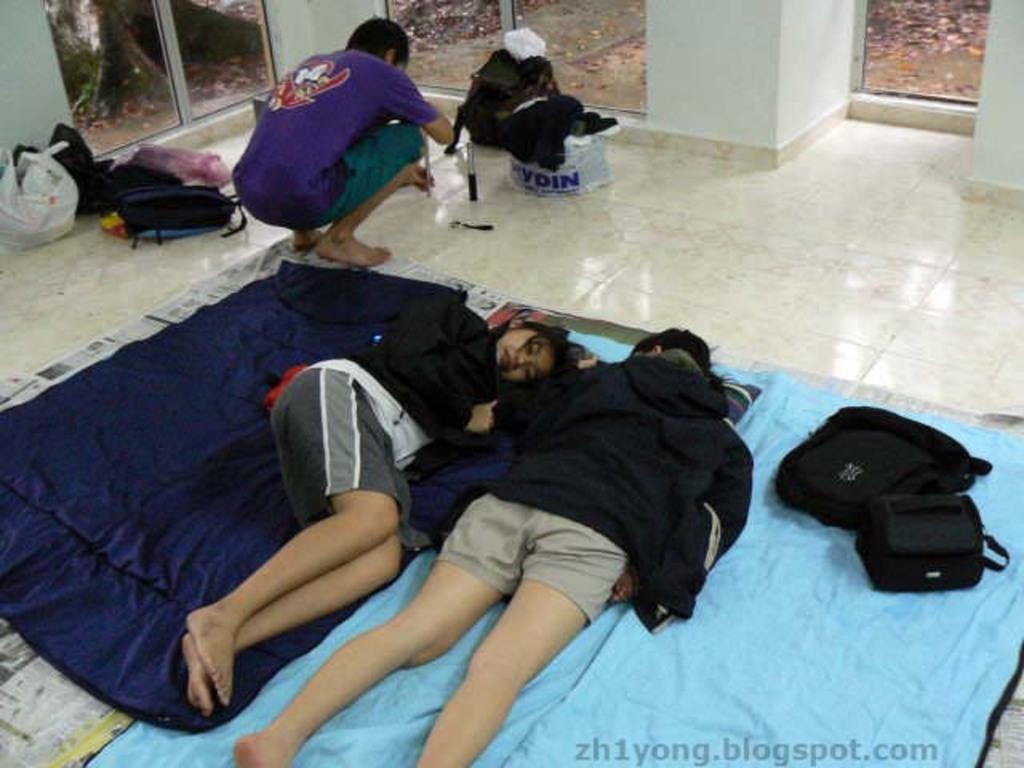What does the text say in blue up top?
Offer a very short reply. Ydin. 